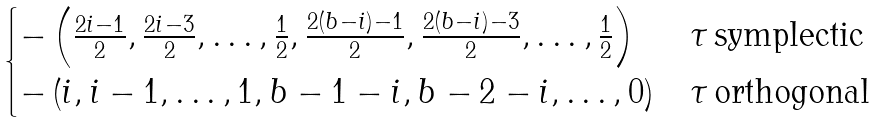Convert formula to latex. <formula><loc_0><loc_0><loc_500><loc_500>\begin{cases} - \left ( \frac { 2 i - 1 } { 2 } , \frac { 2 i - 3 } { 2 } , \dots , \frac { 1 } { 2 } , \frac { 2 ( b - i ) - 1 } { 2 } , \frac { 2 ( b - i ) - 3 } { 2 } , \dots , \frac { 1 } { 2 } \right ) & \tau \, \text {symplectic} \\ - \left ( i , i - 1 , \dots , 1 , b - 1 - i , b - 2 - i , \dots , 0 \right ) & \tau \, \text {orthogonal} \end{cases}</formula> 